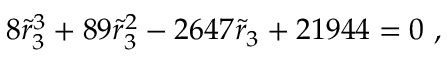<formula> <loc_0><loc_0><loc_500><loc_500>8 { \tilde { r } } _ { 3 } ^ { 3 } + 8 9 { \tilde { r } } _ { 3 } ^ { 2 } - 2 6 4 7 { \tilde { r } } _ { 3 } + 2 1 9 4 4 = 0 \ ,</formula> 